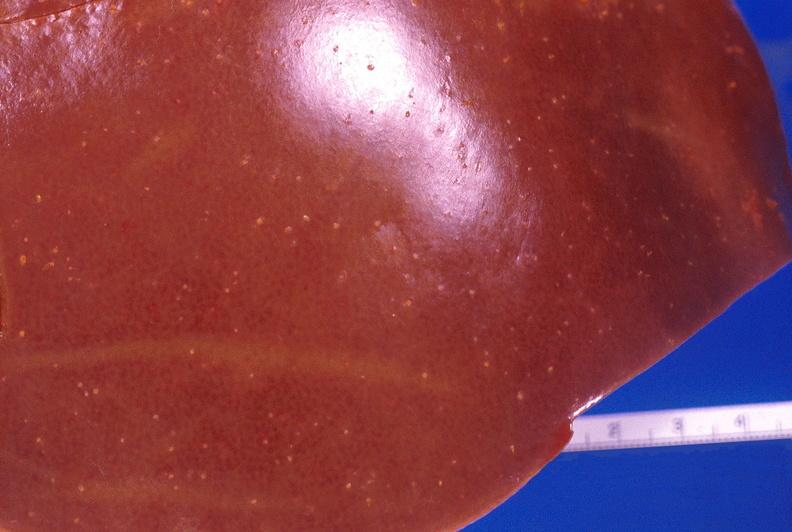does malignant lymphoma show liver, candida abscesses?
Answer the question using a single word or phrase. No 